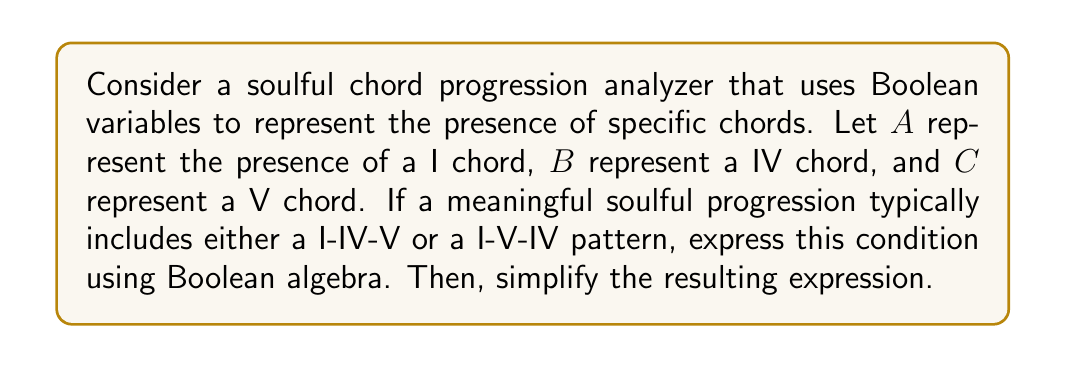Solve this math problem. Let's approach this step-by-step:

1) First, we need to express the two typical soulful progressions using Boolean algebra:
   - I-IV-V progression: $A \wedge B \wedge C$
   - I-V-IV progression: $A \wedge C \wedge B$

2) The question asks for either of these progressions, so we use the OR operator ($\vee$):
   $$(A \wedge B \wedge C) \vee (A \wedge C \wedge B)$$

3) Now, let's simplify this expression:
   $$(A \wedge B \wedge C) \vee (A \wedge C \wedge B)$$
   $$= A \wedge [(B \wedge C) \vee (C \wedge B)]$$ (Factoring out $A$)

4) Notice that $(B \wedge C)$ and $(C \wedge B)$ are equivalent due to the commutative property of AND. So we can simplify further:
   $$= A \wedge (B \wedge C)$$

5) This simplified expression represents the presence of all three chords (I, IV, and V) in the progression, regardless of the order of IV and V.
Answer: $A \wedge (B \wedge C)$ 